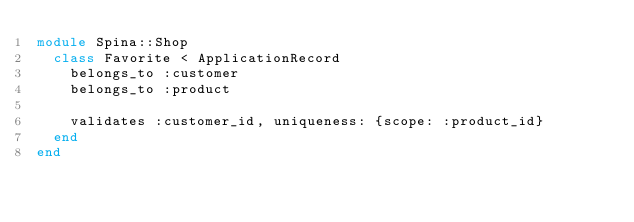Convert code to text. <code><loc_0><loc_0><loc_500><loc_500><_Ruby_>module Spina::Shop
  class Favorite < ApplicationRecord
    belongs_to :customer
    belongs_to :product

    validates :customer_id, uniqueness: {scope: :product_id}
  end
end</code> 